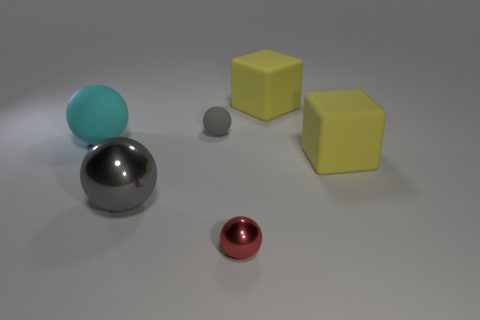How many green objects are matte spheres or tiny matte spheres?
Ensure brevity in your answer.  0. Does the cyan thing have the same material as the red thing in front of the cyan rubber object?
Offer a very short reply. No. Is the number of big matte blocks that are on the left side of the gray rubber object the same as the number of cyan rubber things on the left side of the cyan matte sphere?
Make the answer very short. Yes. There is a gray metal object; is it the same size as the yellow thing that is in front of the big cyan matte sphere?
Provide a short and direct response. Yes. Is the number of red balls that are behind the cyan rubber ball greater than the number of yellow matte cubes?
Offer a very short reply. No. What number of yellow rubber cylinders have the same size as the cyan rubber sphere?
Give a very brief answer. 0. Do the cyan matte ball that is behind the red thing and the yellow block in front of the big matte ball have the same size?
Your response must be concise. Yes. Are there more gray objects behind the large rubber sphere than big gray things behind the big gray object?
Provide a succinct answer. Yes. How many other objects have the same shape as the tiny red thing?
Keep it short and to the point. 3. What is the material of the ball that is the same size as the red thing?
Your response must be concise. Rubber. 